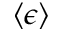<formula> <loc_0><loc_0><loc_500><loc_500>\left \langle \epsilon \right \rangle</formula> 